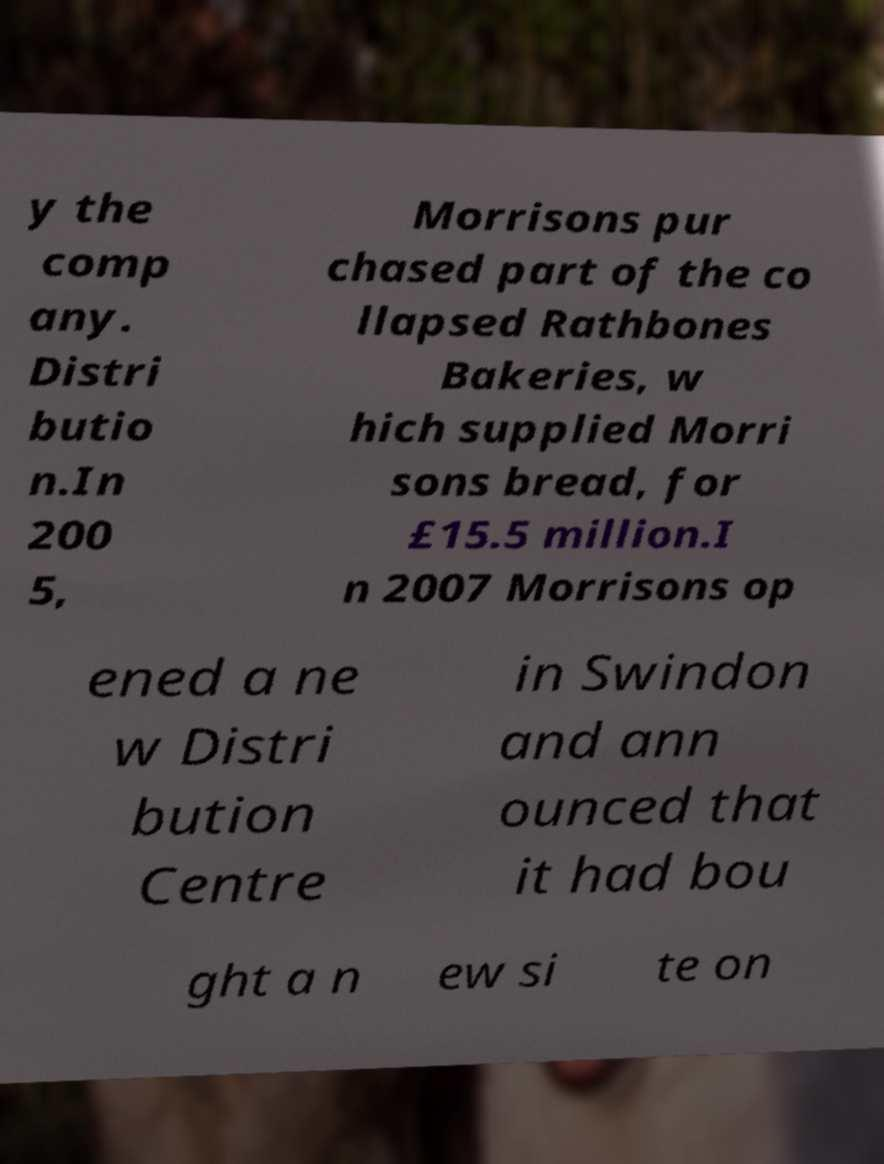Could you extract and type out the text from this image? y the comp any. Distri butio n.In 200 5, Morrisons pur chased part of the co llapsed Rathbones Bakeries, w hich supplied Morri sons bread, for £15.5 million.I n 2007 Morrisons op ened a ne w Distri bution Centre in Swindon and ann ounced that it had bou ght a n ew si te on 